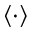Convert formula to latex. <formula><loc_0><loc_0><loc_500><loc_500>\langle \cdot \rangle</formula> 